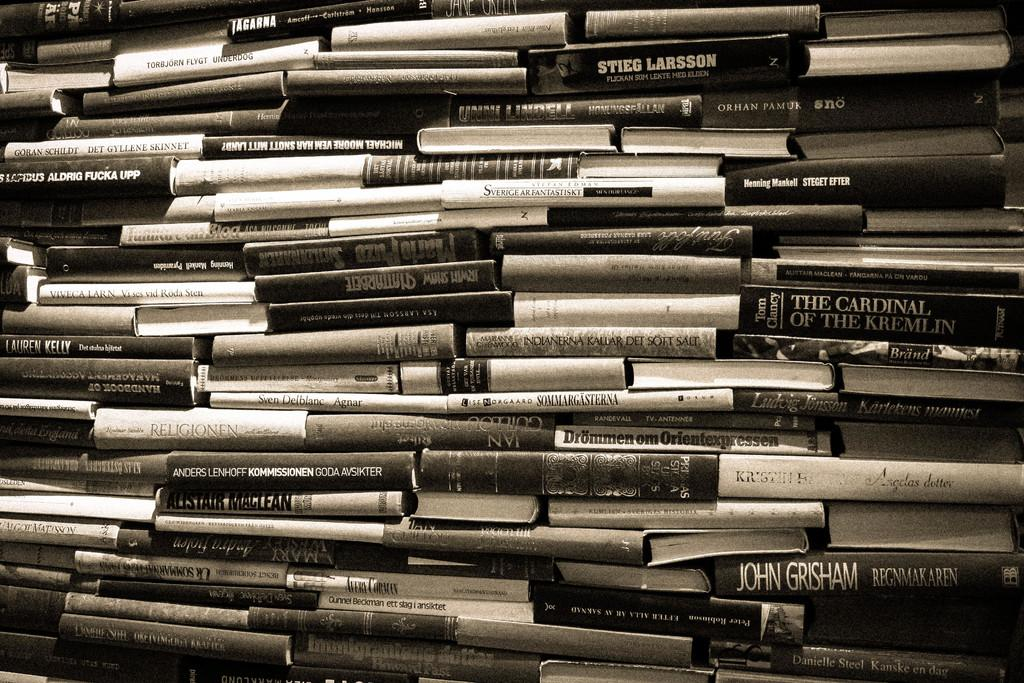<image>
Write a terse but informative summary of the picture. A large stack of books, including some by John Grisham and Tom Clancy. 